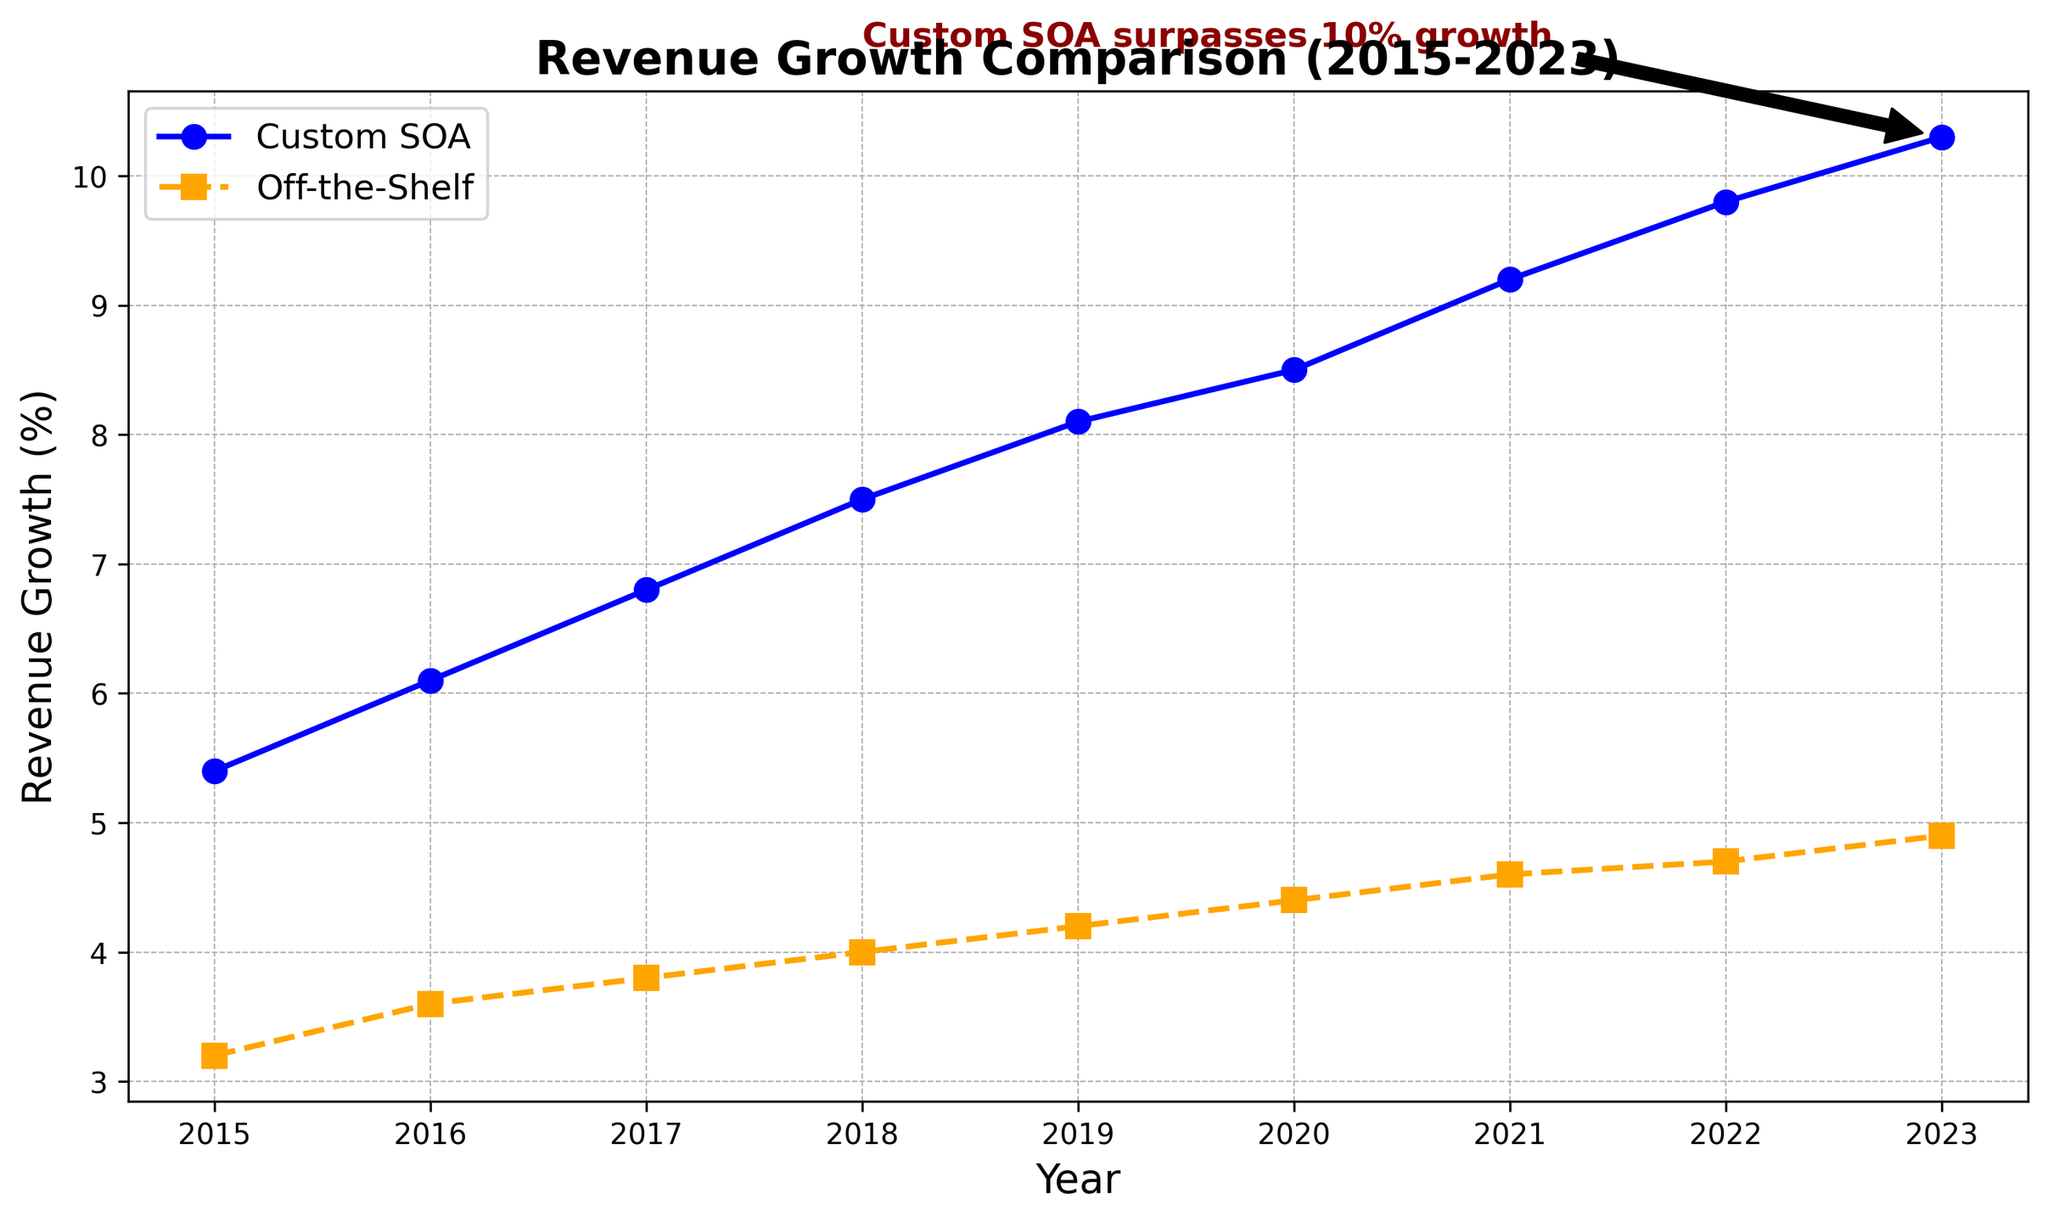How does the revenue growth of companies using custom SOA solutions compare to those using off-the-shelf software in 2023? Look at the 2023 data points for both custom SOA and off-the-shelf software. The custom SOA shows 10.3% growth, while the off-the-shelf shows 4.9%.
Answer: Custom SOA has a higher growth rate What is the overall trend of revenue growth for custom SOA over the years 2015 to 2023? Observe the line representing custom SOA from 2015 to 2023. The line shows a consistent upward trend from 5.4% in 2015 to 10.3% in 2023.
Answer: Increasing trend How does the revenue growth difference between custom SOA and off-the-shelf software evolve from 2015 to 2023? Note the difference in growth rates for each year and observe how it changes: 2.2% in 2015, gradually increasing each year up to 5.4% in 2023.
Answer: The difference increases over time Which year marks the point when custom SOA revenue growth surpasses 10%? Refer to the annotation text and the plot; the annotation indicates the custom SOA growth surpasses 10% in 2023.
Answer: 2023 Between which years did custom SOA experience the most significant growth in revenue? Check the slope of the custom SOA line between consecutive years and find the steepest slope. The increase from 2016 (6.1%) to 2017 (6.8%) appears significant, but from 2022 (9.8%) to 2023 (10.3%) is slightly less steep.
Answer: 2016 to 2017 What is the average revenue growth for off-the-shelf software from 2015 to 2023? Calculate the sum of all off-the-shelf growth percentages and divide by the number of years: (3.2 + 3.6 + 3.8 + 4.0 + 4.2 + 4.4 + 4.6 + 4.7 + 4.9) / 9. This equals 37.4 / 9.
Answer: 4.16% If both trends continue, will off-the-shelf software ever catch up with custom SOA in terms of revenue growth? Given that the gap between the two is widening over time, it is unlikely for off-the-shelf software to catch up if the current trends persist.
Answer: Unlikely Which solution shows more stable revenue growth over time? Analyze the variability in the plotted lines. Off-the-shelf software has a more consistent, less steep slope compared to the steeper, accelerating rise seen in custom SOA.
Answer: Off-the-shelf Compare the revenue growth rates for custom SOA and off-the-shelf software in 2020. Check the data points for 2020: custom SOA is 8.5%, and off-the-shelf is 4.4%.
Answer: Custom SOA is higher What color represents custom SOA in the plot? Identify the line with markers for custom SOA, which is plotted in blue.
Answer: Blue 